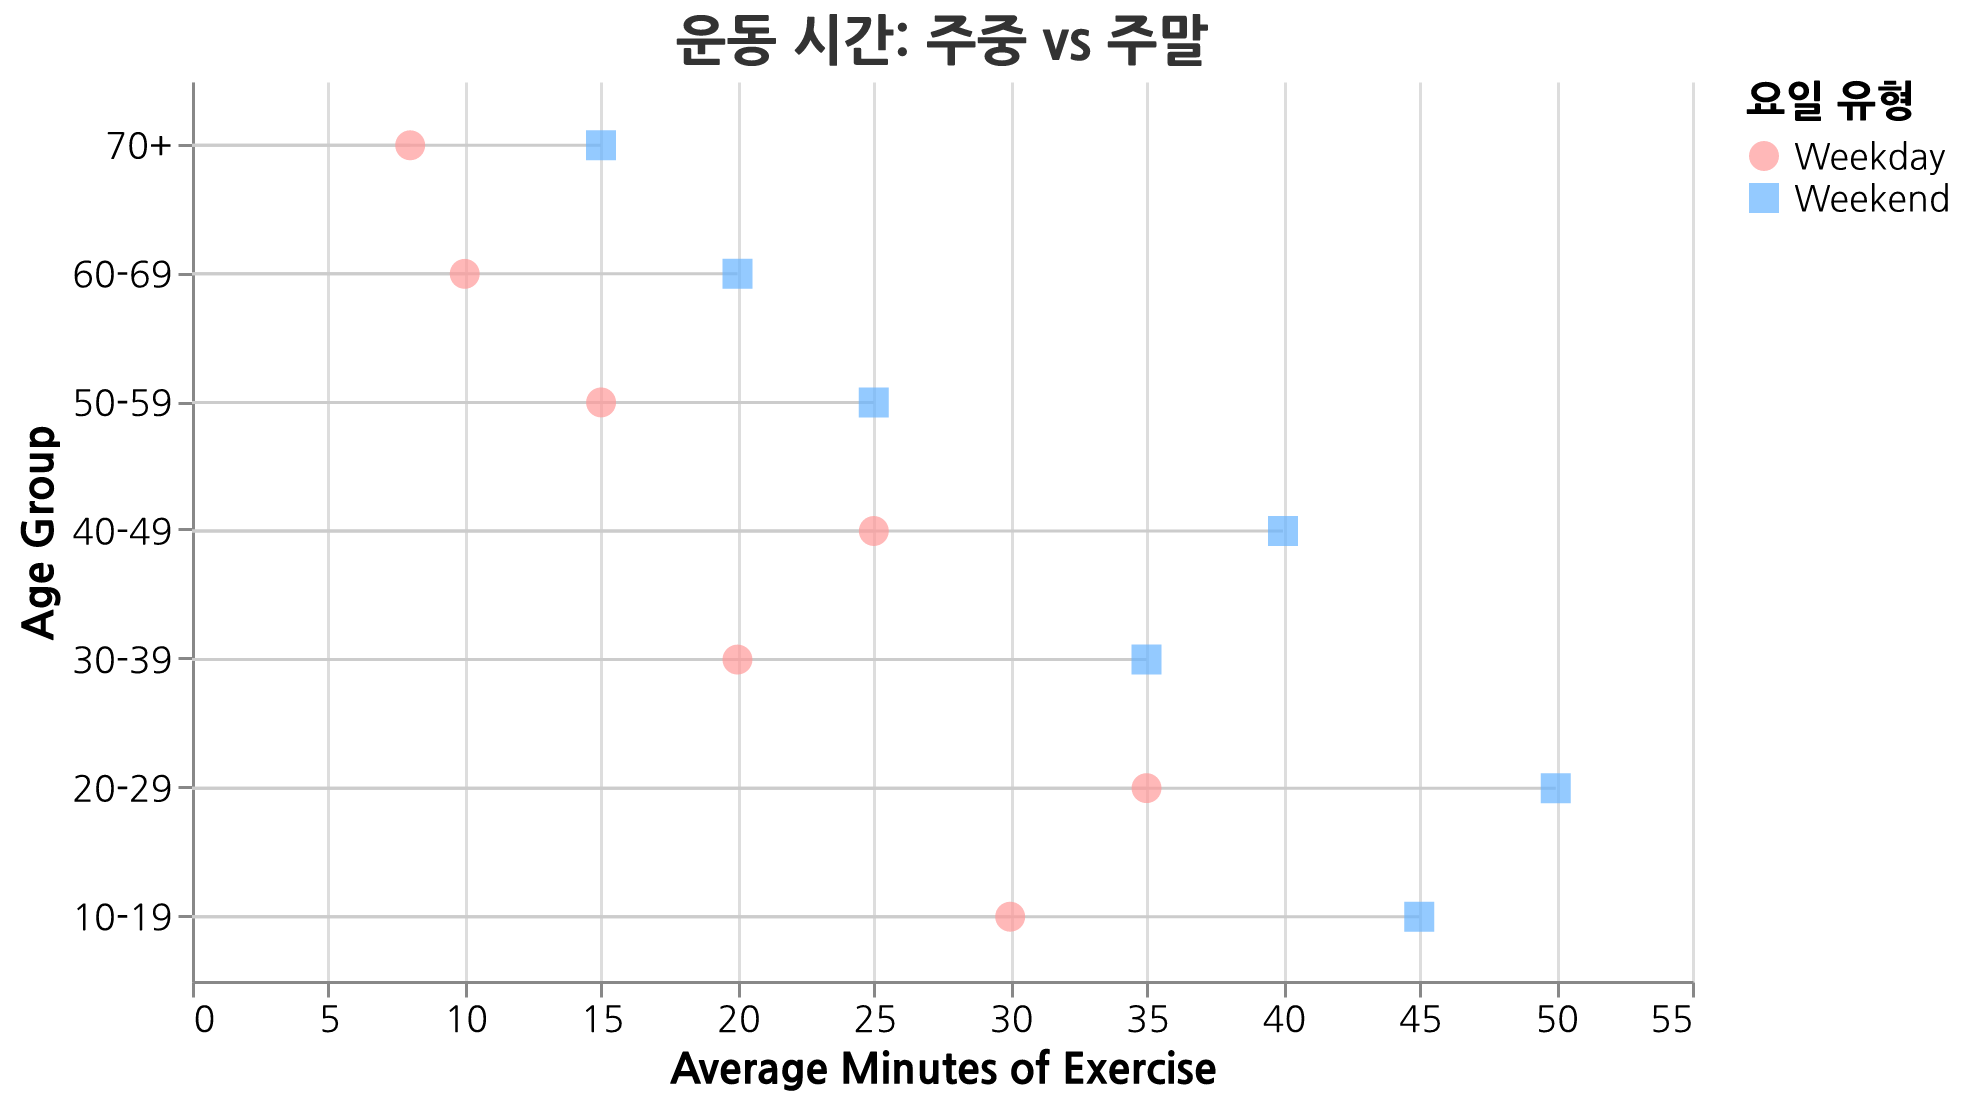What is the title of the figure? The title is shown at the top of the figure. It is written in Korean and reads "운동 시간: 주중 vs 주말" which translates to "Exercise Time: Weekdays vs Weekends".
Answer: 운동 시간: 주중 vs 주말 Which age group exercises the least on weekends? By comparing the average minutes of exercise on weekends for each age group, we see that the "70+" age group has the lowest value, exercising for only 15 minutes.
Answer: 70+ What is the difference in exercise time between weekdays and weekends for the 20-29 age group? For the 20-29 age group, the exercise time on weekdays is 35 minutes, and on weekends it is 50 minutes. The difference is 50 - 35 = 15 minutes.
Answer: 15 minutes Which age group has the largest increase in exercise time from weekdays to weekends? We need to compare the differences (Weekends - Weekdays) for each age group. The largest difference is observed in the 40-49 age group, where the exercise time increases from 25 to 40 minutes, a difference of 15 minutes.
Answer: 40-49 How many age groups exercise more than 30 minutes on weekends? By checking the exercise times for weekends of each group, we find that the age groups 10-19, 20-29, 30-39, and 40-49 all exercise more than 30 minutes on weekends. Thus, there are 4 such age groups.
Answer: 4 What color represents weekend exercise time on the plot? The color legend for "Day Type" indicates that the weekend exercise time is represented by the blue color.
Answer: Blue What shape is used to represent weekday exercise time on the plot? The legend for "Day Type" shows that the weekday exercise time is represented by a circle shape.
Answer: Circle Which two age groups have the closest exercise times on weekdays? By comparing weekday exercise times, we see that the 50-59 and 60-69 age groups have closely aligned times of 15 and 10 minutes, respectively, and so do the 60-69 and 70+ age groups with times of 10 and 8 minutes, respectively. The two closest are 60-69 and 70+, with a difference of only 2 minutes.
Answer: 60-69 and 70+ For the 50-59 age group, what is the percentage increase in exercise time from weekdays to weekends? The exercise time for the 50-59 age group increases from 15 minutes on weekdays to 25 minutes on weekends. The percentage increase is calculated by (25 - 15) / 15 * 100% = 66.67%.
Answer: 66.67% What is the overall trend in exercise habits comparing weekdays to weekends across all age groups? The Dumbbell Plot shows that for all age groups, the exercise time increases from weekdays to weekends. This indicates a clear trend of more exercise being done on weekends compared to weekdays across all age groups.
Answer: More exercise on weekends 